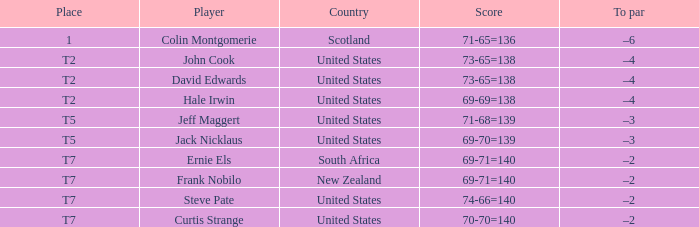What is the name of the golfer that has the score of 73-65=138? John Cook, David Edwards. 